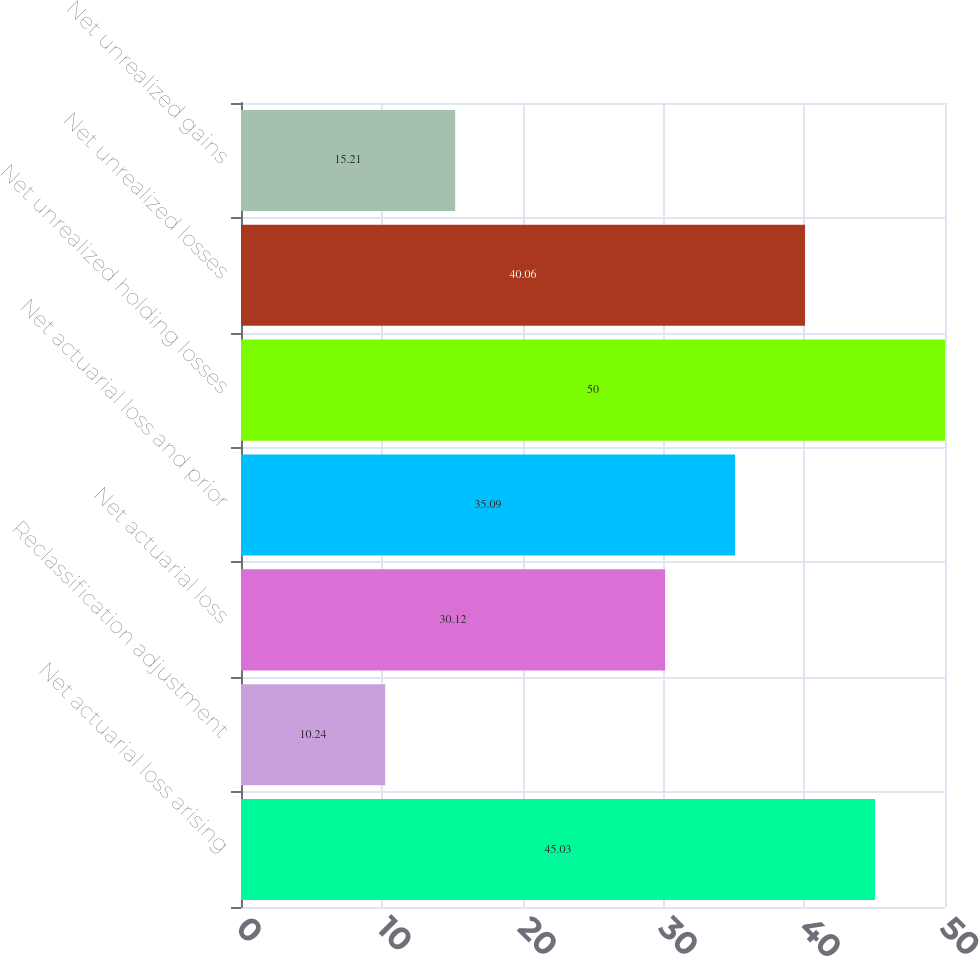Convert chart to OTSL. <chart><loc_0><loc_0><loc_500><loc_500><bar_chart><fcel>Net actuarial loss arising<fcel>Reclassification adjustment<fcel>Net actuarial loss<fcel>Net actuarial loss and prior<fcel>Net unrealized holding losses<fcel>Net unrealized losses<fcel>Net unrealized gains<nl><fcel>45.03<fcel>10.24<fcel>30.12<fcel>35.09<fcel>50<fcel>40.06<fcel>15.21<nl></chart> 